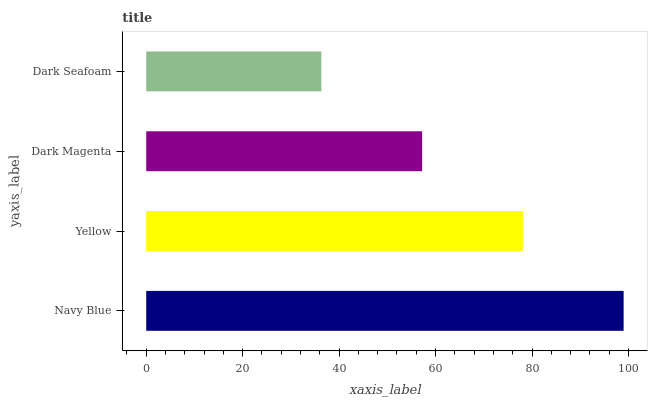Is Dark Seafoam the minimum?
Answer yes or no. Yes. Is Navy Blue the maximum?
Answer yes or no. Yes. Is Yellow the minimum?
Answer yes or no. No. Is Yellow the maximum?
Answer yes or no. No. Is Navy Blue greater than Yellow?
Answer yes or no. Yes. Is Yellow less than Navy Blue?
Answer yes or no. Yes. Is Yellow greater than Navy Blue?
Answer yes or no. No. Is Navy Blue less than Yellow?
Answer yes or no. No. Is Yellow the high median?
Answer yes or no. Yes. Is Dark Magenta the low median?
Answer yes or no. Yes. Is Dark Seafoam the high median?
Answer yes or no. No. Is Yellow the low median?
Answer yes or no. No. 